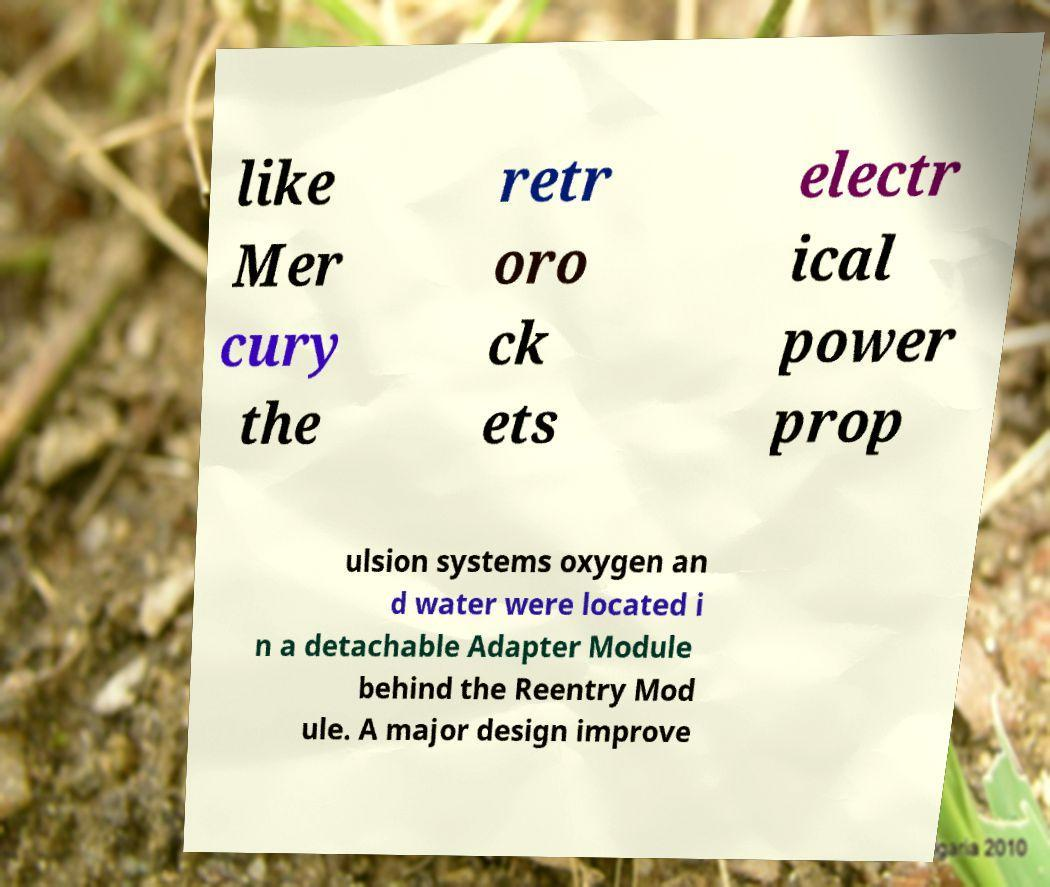What messages or text are displayed in this image? I need them in a readable, typed format. like Mer cury the retr oro ck ets electr ical power prop ulsion systems oxygen an d water were located i n a detachable Adapter Module behind the Reentry Mod ule. A major design improve 